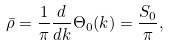Convert formula to latex. <formula><loc_0><loc_0><loc_500><loc_500>\bar { \rho } = \frac { 1 } { \pi } \frac { d } { d k } \Theta _ { 0 } ( k ) = \frac { S _ { 0 } } { \pi } ,</formula> 